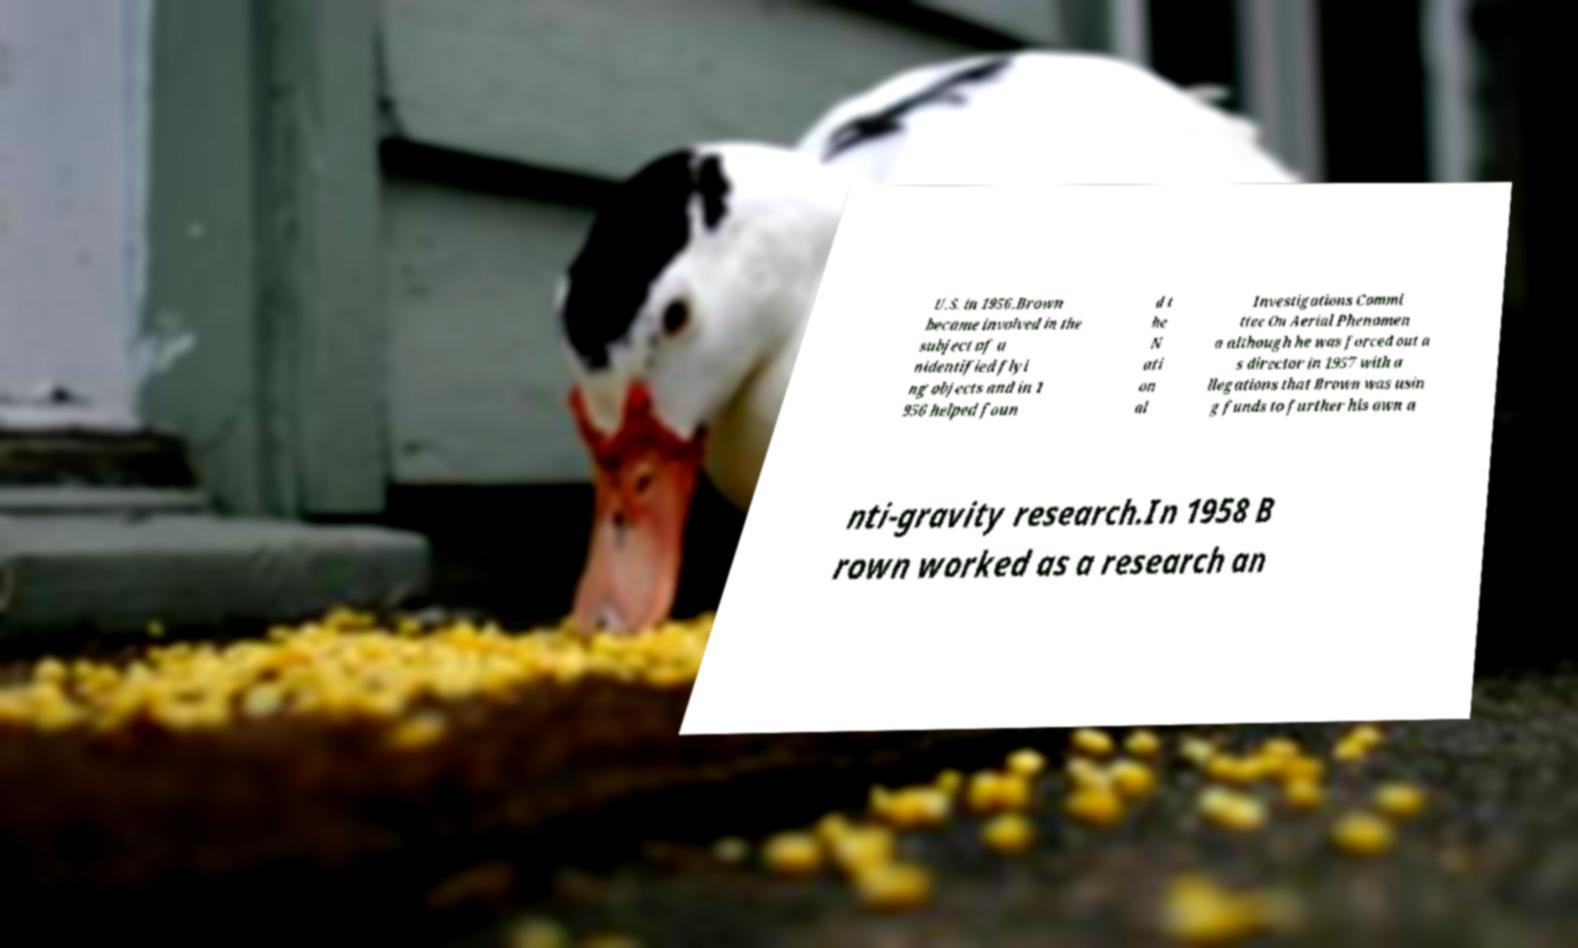For documentation purposes, I need the text within this image transcribed. Could you provide that? U.S. in 1956.Brown became involved in the subject of u nidentified flyi ng objects and in 1 956 helped foun d t he N ati on al Investigations Commi ttee On Aerial Phenomen a although he was forced out a s director in 1957 with a llegations that Brown was usin g funds to further his own a nti-gravity research.In 1958 B rown worked as a research an 